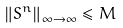Convert formula to latex. <formula><loc_0><loc_0><loc_500><loc_500>\left \| S ^ { n } \right \| _ { \infty \rightarrow \infty } \leq M</formula> 